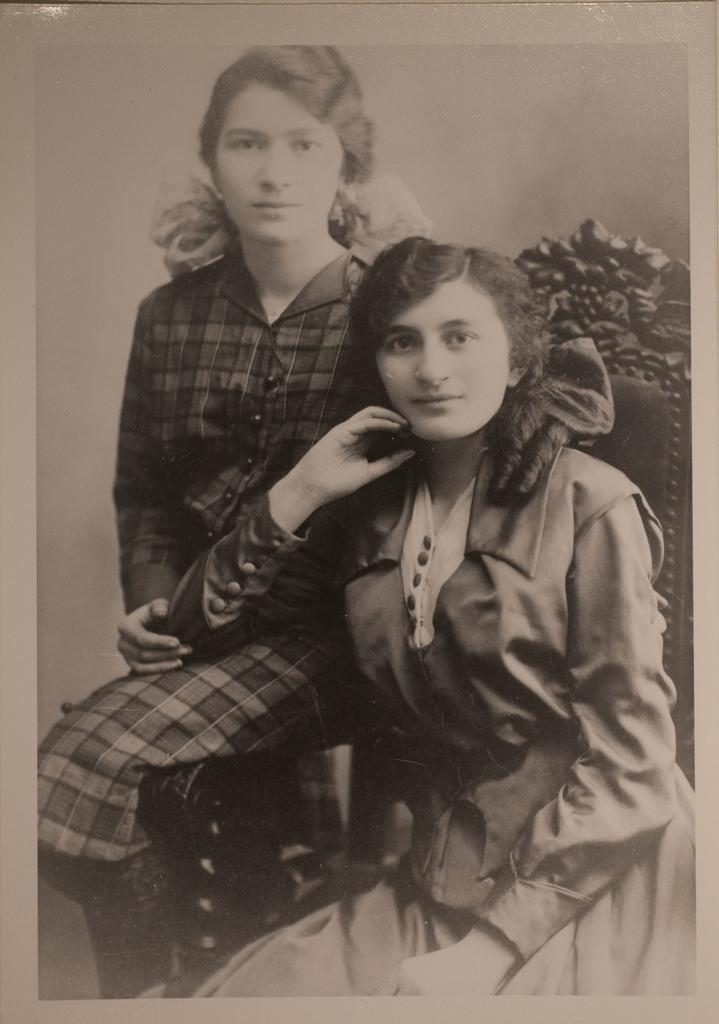What is the color scheme of the image? The image is black and white. What can be seen in the image? There is a girl sitting on a chair, and another girl sitting with her elbow on the first girl's leg. Can you describe the position of the second girl in relation to the first girl? The second girl is sitting with her elbow on the first girl's leg. What type of slope can be seen in the background of the image? There is no slope present in the image; it is a black and white image of two girls sitting on a chair. 